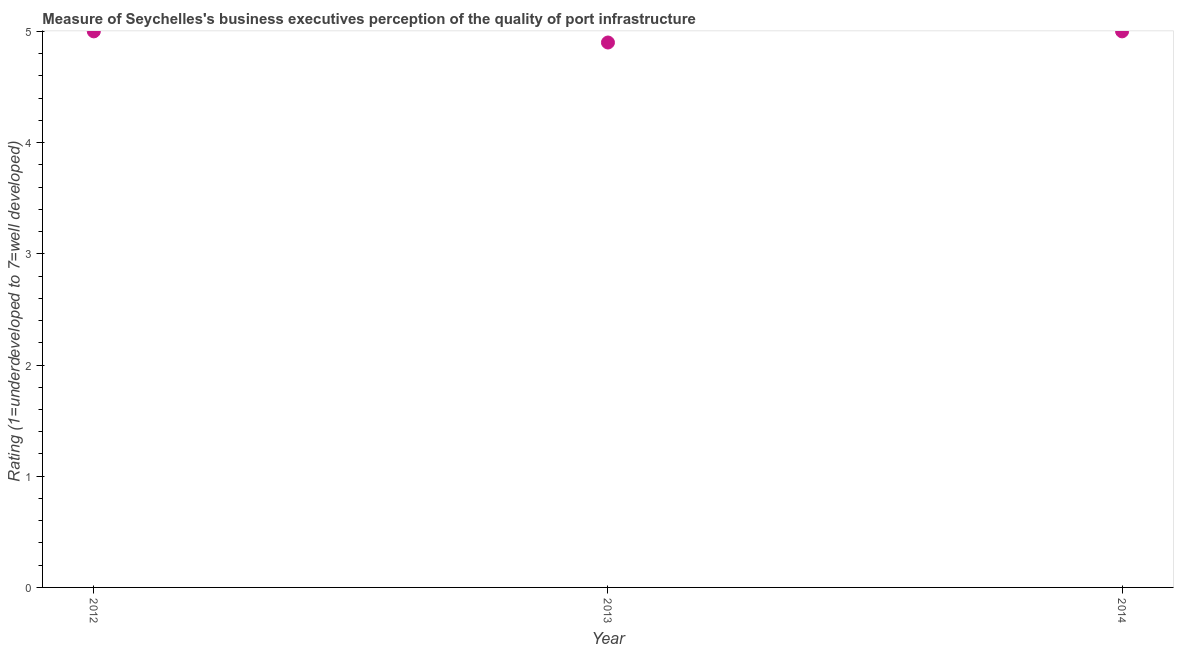What is the rating measuring quality of port infrastructure in 2012?
Offer a very short reply. 5. Across all years, what is the maximum rating measuring quality of port infrastructure?
Give a very brief answer. 5. Across all years, what is the minimum rating measuring quality of port infrastructure?
Make the answer very short. 4.9. What is the difference between the rating measuring quality of port infrastructure in 2012 and 2014?
Provide a succinct answer. 0. What is the average rating measuring quality of port infrastructure per year?
Offer a terse response. 4.97. In how many years, is the rating measuring quality of port infrastructure greater than 1 ?
Provide a succinct answer. 3. Do a majority of the years between 2012 and 2014 (inclusive) have rating measuring quality of port infrastructure greater than 1.8 ?
Ensure brevity in your answer.  Yes. What is the difference between the highest and the second highest rating measuring quality of port infrastructure?
Your answer should be very brief. 0. What is the difference between the highest and the lowest rating measuring quality of port infrastructure?
Offer a very short reply. 0.1. In how many years, is the rating measuring quality of port infrastructure greater than the average rating measuring quality of port infrastructure taken over all years?
Your response must be concise. 2. Does the rating measuring quality of port infrastructure monotonically increase over the years?
Keep it short and to the point. No. How many dotlines are there?
Provide a short and direct response. 1. What is the difference between two consecutive major ticks on the Y-axis?
Give a very brief answer. 1. Are the values on the major ticks of Y-axis written in scientific E-notation?
Provide a succinct answer. No. Does the graph contain any zero values?
Keep it short and to the point. No. What is the title of the graph?
Keep it short and to the point. Measure of Seychelles's business executives perception of the quality of port infrastructure. What is the label or title of the Y-axis?
Provide a succinct answer. Rating (1=underdeveloped to 7=well developed) . What is the Rating (1=underdeveloped to 7=well developed)  in 2013?
Provide a succinct answer. 4.9. What is the Rating (1=underdeveloped to 7=well developed)  in 2014?
Offer a very short reply. 5. What is the difference between the Rating (1=underdeveloped to 7=well developed)  in 2012 and 2013?
Your response must be concise. 0.1. What is the difference between the Rating (1=underdeveloped to 7=well developed)  in 2013 and 2014?
Your answer should be very brief. -0.1. What is the ratio of the Rating (1=underdeveloped to 7=well developed)  in 2012 to that in 2013?
Keep it short and to the point. 1.02. What is the ratio of the Rating (1=underdeveloped to 7=well developed)  in 2013 to that in 2014?
Give a very brief answer. 0.98. 